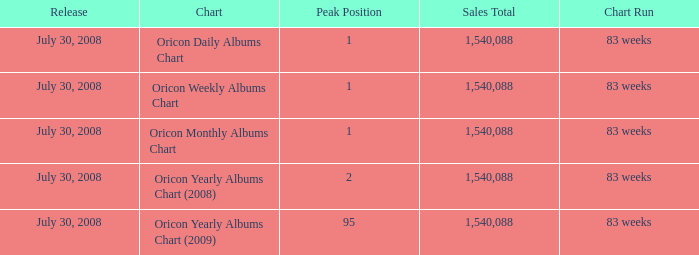Which Chart has a Peak Position of 1? Oricon Daily Albums Chart, Oricon Weekly Albums Chart, Oricon Monthly Albums Chart. 